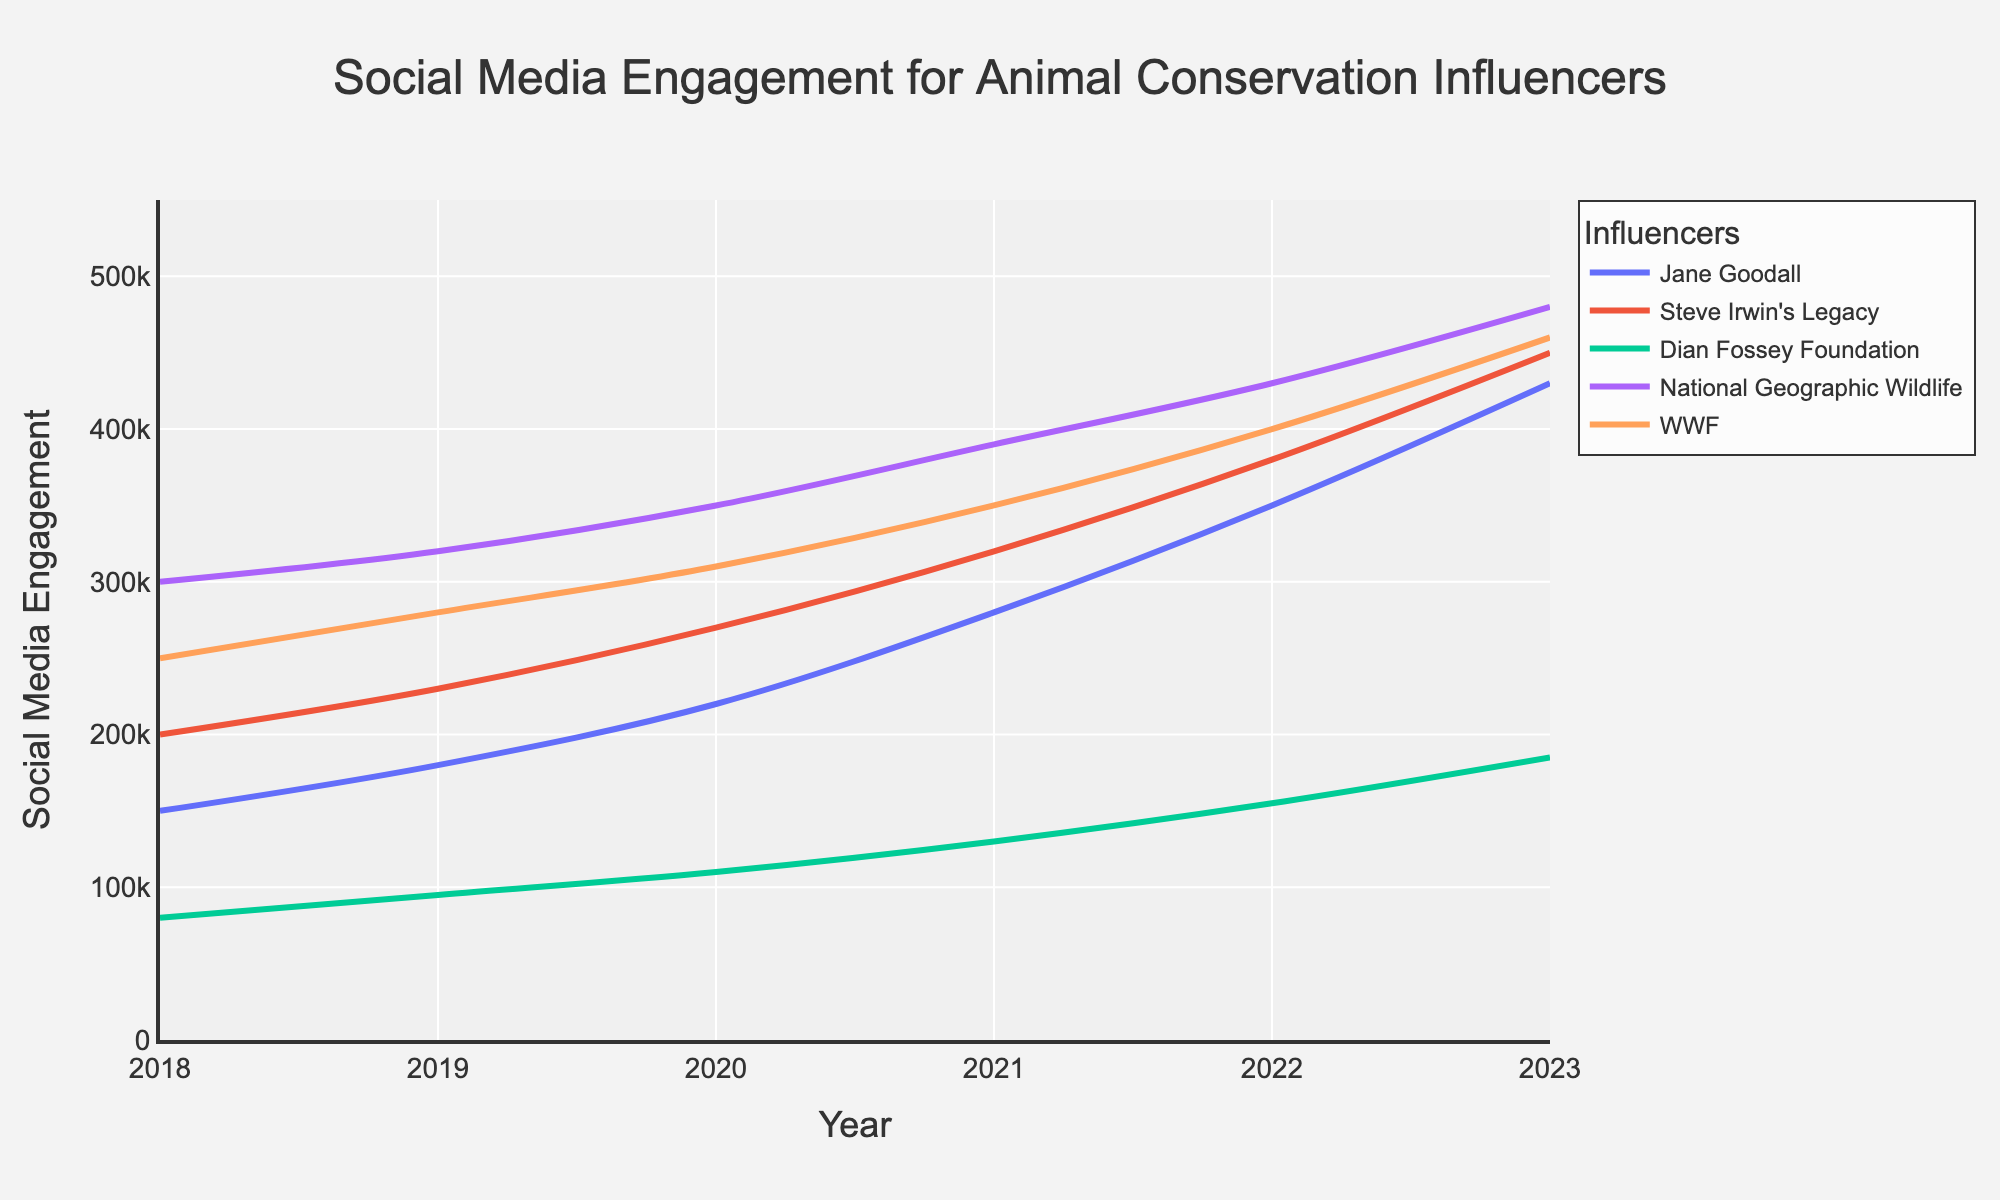what is the difference in social media engagement between Jane Goodall and Dian Fossey Foundation in 2023? Jane Goodall has an engagement of 430,000 in 2023 while Dian Fossey Foundation has 185,000. The difference is 430,000 - 185,000 = 245,000
Answer: 245,000 Which influencer showed the greatest increase in engagement between 2018 and 2023? Calculate the increase for each influencer by subtracting their engagement in 2018 from their engagement in 2023. Jane Goodall's increase is from 150,000 to 430,000 (280,000), Steve Irwin's Legacy's increase is from 200,000 to 450,000 (250,000), Dian Fossey Foundation's increase is from 80,000 to 185,000 (105,000), National Geographic Wildlife's increase is from 300,000 to 480,000 (180,000), and WWF's increase is from 250,000 to 460,000 (210,000). Steve Irwin's Legacy has the greatest increase with 250,000
Answer: Steve Irwin's Legacy What is the average social media engagement for National Geographic Wildlife over the 5-year period? Add all the yearly engagements for National Geographic Wildlife and then divide by the number of years: (300,000 + 320,000 + 350,000 + 390,000 + 430,000 + 480,000) / 6 = 2,270,000 / 6 ≈ 378,333.33
Answer: ≈378,333.33 How many influencers had more than 400,000 engagement in 2023? By looking at the 2023 data, Jane Goodall, Steve Irwin's Legacy, National Geographic Wildlife, and WWF all had more than 400,000 engagements. So, there are 4 influencers.
Answer: 4 Identify the year when Dian Fossey Foundation's engagement surpassed 100,000? Dian Fossey Foundation crossed over 100,000 in 2020 as indicated by the engagement value: from 95,000 in 2019 to 110,000 in 2020
Answer: 2020 Between 2018 and 2023, which year did Jane Goodall see the biggest single-year increase in engagement? Compare the year-over-year changes: 2018-2019 (30,000), 2019-2020 (40,000), 2020-2021 (60,000), 2021-2022 (70,000), 2022-2023 (80,000). The biggest increase was from 2022 to 2023.
Answer: 2022-2023 Compare the growth rates of Steve Irwin's Legacy and WWF between 2020 and 2023. Which one grew faster? Calculate the growth for each from 2020 to 2023. Steve Irwin's Legacy: (450,000 - 270,000) / 270,000 ≈ 0.67 (67%), WWF: (460,000 - 310,000) / 310,000 ≈ 0.48 (48%). Steve Irwin's Legacy grew faster.
Answer: Steve Irwin's Legacy 